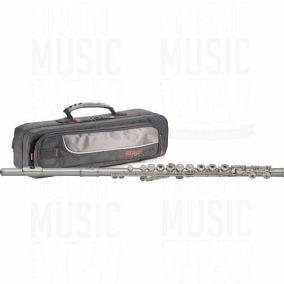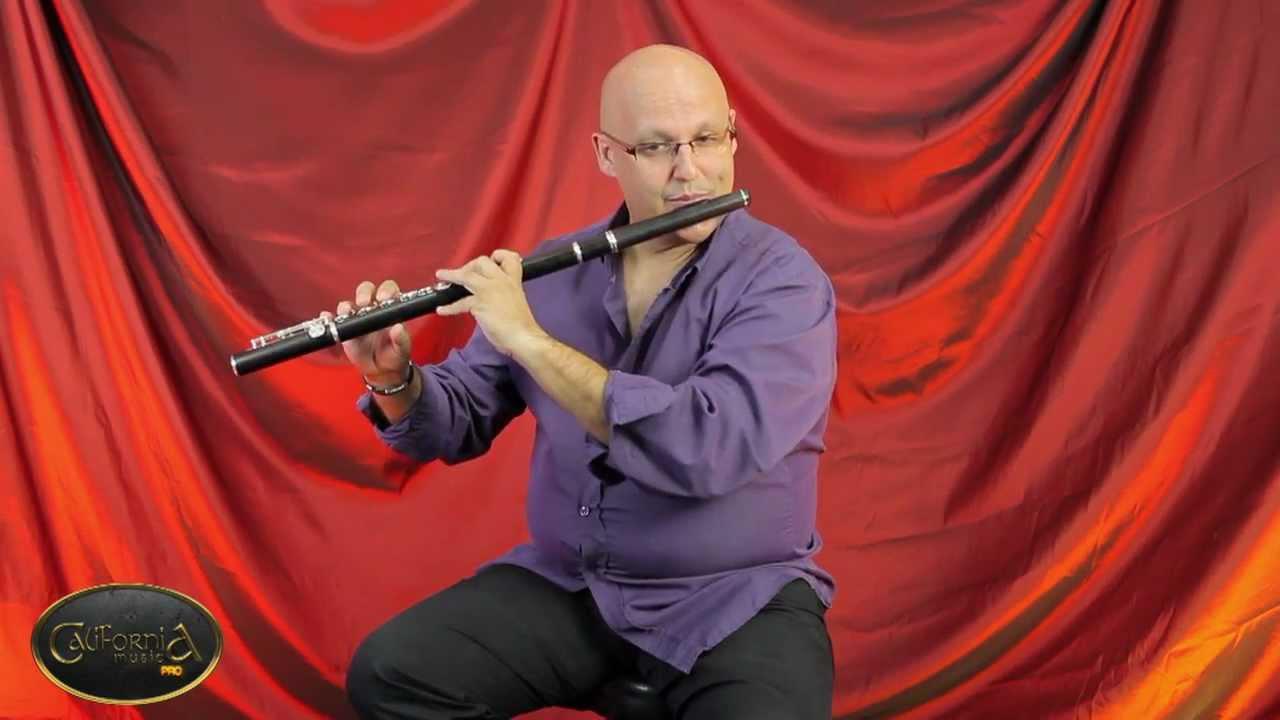The first image is the image on the left, the second image is the image on the right. For the images displayed, is the sentence "The left image includes at least two black tube-shaped flute parts displayed horizontally but spaced apart." factually correct? Answer yes or no. No. The first image is the image on the left, the second image is the image on the right. Examine the images to the left and right. Is the description "The clarinet in the image on the left is taken apart into pieces." accurate? Answer yes or no. No. 